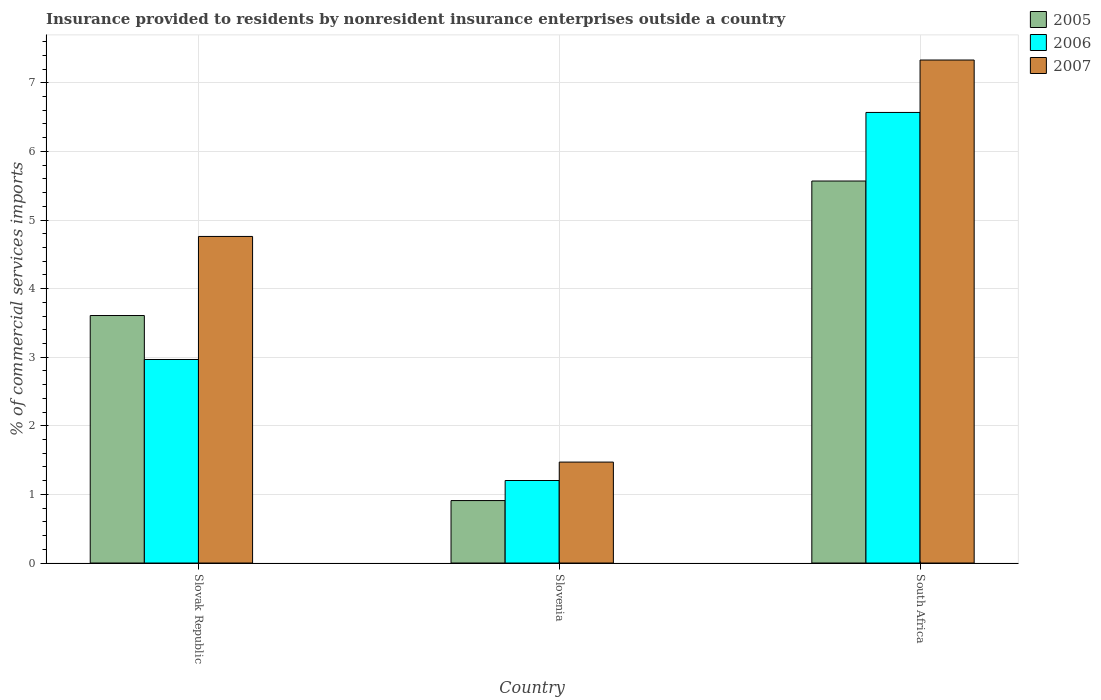How many bars are there on the 2nd tick from the right?
Offer a terse response. 3. What is the label of the 3rd group of bars from the left?
Your answer should be compact. South Africa. In how many cases, is the number of bars for a given country not equal to the number of legend labels?
Your answer should be very brief. 0. What is the Insurance provided to residents in 2007 in Slovak Republic?
Your response must be concise. 4.76. Across all countries, what is the maximum Insurance provided to residents in 2007?
Offer a terse response. 7.33. Across all countries, what is the minimum Insurance provided to residents in 2005?
Your response must be concise. 0.91. In which country was the Insurance provided to residents in 2007 maximum?
Your answer should be compact. South Africa. In which country was the Insurance provided to residents in 2006 minimum?
Your answer should be compact. Slovenia. What is the total Insurance provided to residents in 2006 in the graph?
Provide a succinct answer. 10.74. What is the difference between the Insurance provided to residents in 2007 in Slovenia and that in South Africa?
Keep it short and to the point. -5.86. What is the difference between the Insurance provided to residents in 2007 in Slovenia and the Insurance provided to residents in 2005 in Slovak Republic?
Keep it short and to the point. -2.14. What is the average Insurance provided to residents in 2005 per country?
Your response must be concise. 3.36. What is the difference between the Insurance provided to residents of/in 2007 and Insurance provided to residents of/in 2005 in Slovak Republic?
Make the answer very short. 1.15. What is the ratio of the Insurance provided to residents in 2007 in Slovak Republic to that in South Africa?
Give a very brief answer. 0.65. What is the difference between the highest and the second highest Insurance provided to residents in 2007?
Your answer should be very brief. -3.29. What is the difference between the highest and the lowest Insurance provided to residents in 2005?
Your answer should be very brief. 4.66. In how many countries, is the Insurance provided to residents in 2006 greater than the average Insurance provided to residents in 2006 taken over all countries?
Keep it short and to the point. 1. Is the sum of the Insurance provided to residents in 2007 in Slovenia and South Africa greater than the maximum Insurance provided to residents in 2006 across all countries?
Your answer should be very brief. Yes. What does the 1st bar from the left in Slovak Republic represents?
Keep it short and to the point. 2005. What does the 1st bar from the right in Slovak Republic represents?
Keep it short and to the point. 2007. How many countries are there in the graph?
Your answer should be very brief. 3. Are the values on the major ticks of Y-axis written in scientific E-notation?
Make the answer very short. No. Does the graph contain any zero values?
Your response must be concise. No. Where does the legend appear in the graph?
Ensure brevity in your answer.  Top right. How many legend labels are there?
Give a very brief answer. 3. What is the title of the graph?
Provide a succinct answer. Insurance provided to residents by nonresident insurance enterprises outside a country. What is the label or title of the Y-axis?
Provide a succinct answer. % of commercial services imports. What is the % of commercial services imports of 2005 in Slovak Republic?
Your answer should be compact. 3.61. What is the % of commercial services imports in 2006 in Slovak Republic?
Provide a short and direct response. 2.97. What is the % of commercial services imports in 2007 in Slovak Republic?
Offer a terse response. 4.76. What is the % of commercial services imports of 2005 in Slovenia?
Make the answer very short. 0.91. What is the % of commercial services imports of 2006 in Slovenia?
Keep it short and to the point. 1.2. What is the % of commercial services imports of 2007 in Slovenia?
Provide a short and direct response. 1.47. What is the % of commercial services imports of 2005 in South Africa?
Your response must be concise. 5.57. What is the % of commercial services imports of 2006 in South Africa?
Keep it short and to the point. 6.57. What is the % of commercial services imports of 2007 in South Africa?
Offer a terse response. 7.33. Across all countries, what is the maximum % of commercial services imports of 2005?
Offer a very short reply. 5.57. Across all countries, what is the maximum % of commercial services imports in 2006?
Your answer should be compact. 6.57. Across all countries, what is the maximum % of commercial services imports of 2007?
Offer a very short reply. 7.33. Across all countries, what is the minimum % of commercial services imports in 2005?
Make the answer very short. 0.91. Across all countries, what is the minimum % of commercial services imports in 2006?
Make the answer very short. 1.2. Across all countries, what is the minimum % of commercial services imports of 2007?
Provide a succinct answer. 1.47. What is the total % of commercial services imports of 2005 in the graph?
Your answer should be very brief. 10.09. What is the total % of commercial services imports of 2006 in the graph?
Give a very brief answer. 10.74. What is the total % of commercial services imports of 2007 in the graph?
Offer a terse response. 13.56. What is the difference between the % of commercial services imports of 2005 in Slovak Republic and that in Slovenia?
Provide a succinct answer. 2.7. What is the difference between the % of commercial services imports in 2006 in Slovak Republic and that in Slovenia?
Provide a succinct answer. 1.76. What is the difference between the % of commercial services imports of 2007 in Slovak Republic and that in Slovenia?
Your answer should be compact. 3.29. What is the difference between the % of commercial services imports in 2005 in Slovak Republic and that in South Africa?
Make the answer very short. -1.96. What is the difference between the % of commercial services imports in 2006 in Slovak Republic and that in South Africa?
Your answer should be very brief. -3.6. What is the difference between the % of commercial services imports in 2007 in Slovak Republic and that in South Africa?
Provide a short and direct response. -2.57. What is the difference between the % of commercial services imports of 2005 in Slovenia and that in South Africa?
Your response must be concise. -4.66. What is the difference between the % of commercial services imports in 2006 in Slovenia and that in South Africa?
Offer a terse response. -5.37. What is the difference between the % of commercial services imports in 2007 in Slovenia and that in South Africa?
Your answer should be very brief. -5.86. What is the difference between the % of commercial services imports in 2005 in Slovak Republic and the % of commercial services imports in 2006 in Slovenia?
Offer a terse response. 2.4. What is the difference between the % of commercial services imports of 2005 in Slovak Republic and the % of commercial services imports of 2007 in Slovenia?
Provide a short and direct response. 2.14. What is the difference between the % of commercial services imports in 2006 in Slovak Republic and the % of commercial services imports in 2007 in Slovenia?
Make the answer very short. 1.5. What is the difference between the % of commercial services imports in 2005 in Slovak Republic and the % of commercial services imports in 2006 in South Africa?
Make the answer very short. -2.96. What is the difference between the % of commercial services imports in 2005 in Slovak Republic and the % of commercial services imports in 2007 in South Africa?
Offer a terse response. -3.72. What is the difference between the % of commercial services imports of 2006 in Slovak Republic and the % of commercial services imports of 2007 in South Africa?
Offer a terse response. -4.37. What is the difference between the % of commercial services imports in 2005 in Slovenia and the % of commercial services imports in 2006 in South Africa?
Offer a very short reply. -5.66. What is the difference between the % of commercial services imports of 2005 in Slovenia and the % of commercial services imports of 2007 in South Africa?
Provide a short and direct response. -6.42. What is the difference between the % of commercial services imports of 2006 in Slovenia and the % of commercial services imports of 2007 in South Africa?
Your answer should be very brief. -6.13. What is the average % of commercial services imports in 2005 per country?
Provide a succinct answer. 3.36. What is the average % of commercial services imports in 2006 per country?
Offer a terse response. 3.58. What is the average % of commercial services imports of 2007 per country?
Provide a succinct answer. 4.52. What is the difference between the % of commercial services imports in 2005 and % of commercial services imports in 2006 in Slovak Republic?
Your answer should be very brief. 0.64. What is the difference between the % of commercial services imports in 2005 and % of commercial services imports in 2007 in Slovak Republic?
Provide a short and direct response. -1.15. What is the difference between the % of commercial services imports of 2006 and % of commercial services imports of 2007 in Slovak Republic?
Offer a very short reply. -1.79. What is the difference between the % of commercial services imports of 2005 and % of commercial services imports of 2006 in Slovenia?
Your answer should be very brief. -0.29. What is the difference between the % of commercial services imports in 2005 and % of commercial services imports in 2007 in Slovenia?
Keep it short and to the point. -0.56. What is the difference between the % of commercial services imports in 2006 and % of commercial services imports in 2007 in Slovenia?
Make the answer very short. -0.27. What is the difference between the % of commercial services imports in 2005 and % of commercial services imports in 2006 in South Africa?
Make the answer very short. -1. What is the difference between the % of commercial services imports of 2005 and % of commercial services imports of 2007 in South Africa?
Provide a succinct answer. -1.76. What is the difference between the % of commercial services imports in 2006 and % of commercial services imports in 2007 in South Africa?
Your answer should be very brief. -0.76. What is the ratio of the % of commercial services imports of 2005 in Slovak Republic to that in Slovenia?
Provide a short and direct response. 3.96. What is the ratio of the % of commercial services imports in 2006 in Slovak Republic to that in Slovenia?
Provide a short and direct response. 2.47. What is the ratio of the % of commercial services imports in 2007 in Slovak Republic to that in Slovenia?
Offer a terse response. 3.24. What is the ratio of the % of commercial services imports in 2005 in Slovak Republic to that in South Africa?
Your response must be concise. 0.65. What is the ratio of the % of commercial services imports of 2006 in Slovak Republic to that in South Africa?
Provide a succinct answer. 0.45. What is the ratio of the % of commercial services imports of 2007 in Slovak Republic to that in South Africa?
Offer a very short reply. 0.65. What is the ratio of the % of commercial services imports of 2005 in Slovenia to that in South Africa?
Keep it short and to the point. 0.16. What is the ratio of the % of commercial services imports of 2006 in Slovenia to that in South Africa?
Keep it short and to the point. 0.18. What is the ratio of the % of commercial services imports in 2007 in Slovenia to that in South Africa?
Your response must be concise. 0.2. What is the difference between the highest and the second highest % of commercial services imports in 2005?
Offer a terse response. 1.96. What is the difference between the highest and the second highest % of commercial services imports in 2006?
Offer a very short reply. 3.6. What is the difference between the highest and the second highest % of commercial services imports of 2007?
Ensure brevity in your answer.  2.57. What is the difference between the highest and the lowest % of commercial services imports of 2005?
Your answer should be very brief. 4.66. What is the difference between the highest and the lowest % of commercial services imports in 2006?
Your response must be concise. 5.37. What is the difference between the highest and the lowest % of commercial services imports in 2007?
Offer a very short reply. 5.86. 